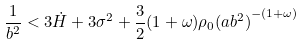<formula> <loc_0><loc_0><loc_500><loc_500>\frac { 1 } { b ^ { 2 } } < 3 \dot { H } + 3 { \sigma } ^ { 2 } + \frac { 3 } 2 ( 1 + \omega ) { \rho } _ { 0 } { ( a b ^ { 2 } ) } ^ { - ( 1 + \omega ) }</formula> 